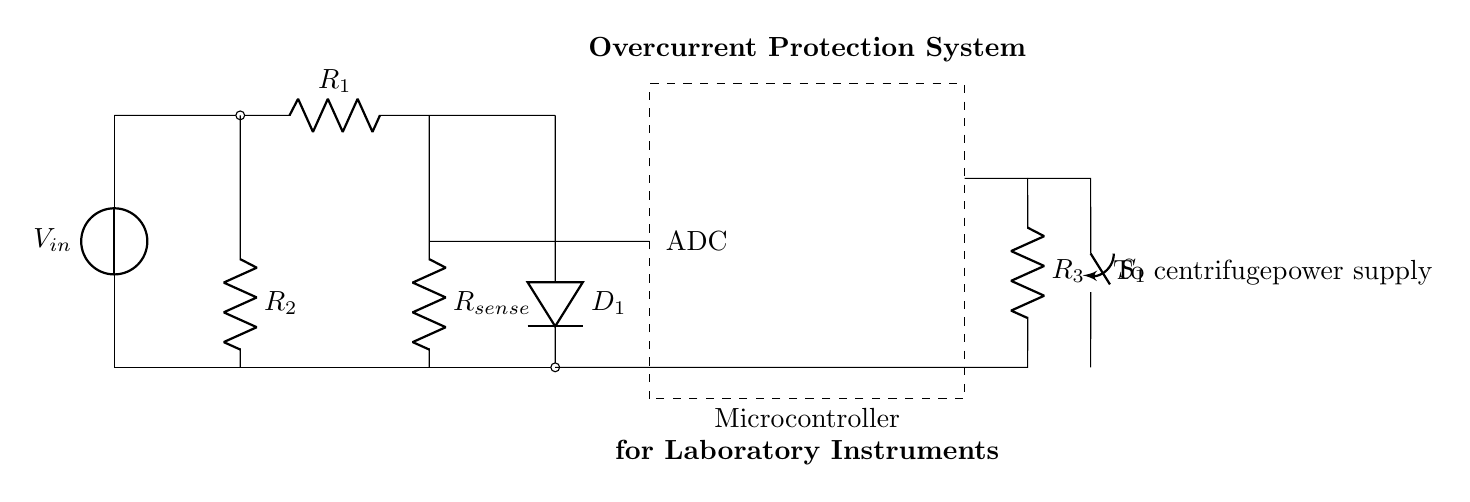What is the function of the switch S1 in this circuit? The switch S1 is used to control the power supply to the centrifuge. When S1 is closed, it allows current to flow to the power supply of the centrifuge.
Answer: Control the power supply What does R_sense measure in this circuit? R_sense measures the current flowing through the circuit that powers the centrifuge. The voltage drop across R_sense is used to determine the current level.
Answer: Current What happens when the current exceeds a certain level? When the current exceeds a predetermined threshold, it triggers the microcontroller to take action, such as opening S1 to cut off power to the centrifuge to prevent damage.
Answer: Triggers protection mechanism Which component analyzes the voltage drop across R_sense? The microcontroller, equipped with an ADC (Analog to Digital Converter), analyzes the voltage drop across R_sense to determine the current flowing through the circuit.
Answer: Microcontroller What are the components included in the protection system? The components include a voltage source, resistors (R1, R2, R3, and R_sense), a diode (D1), a switch (S1), and a microcontroller.
Answer: Voltage source, resistors, diode, switch, microcontroller How does the diode D1 contribute to the circuit? The diode D1 allows current to flow in one direction and protects the circuit from reverse voltage which could damage other components.
Answer: Allows unidirectional current 